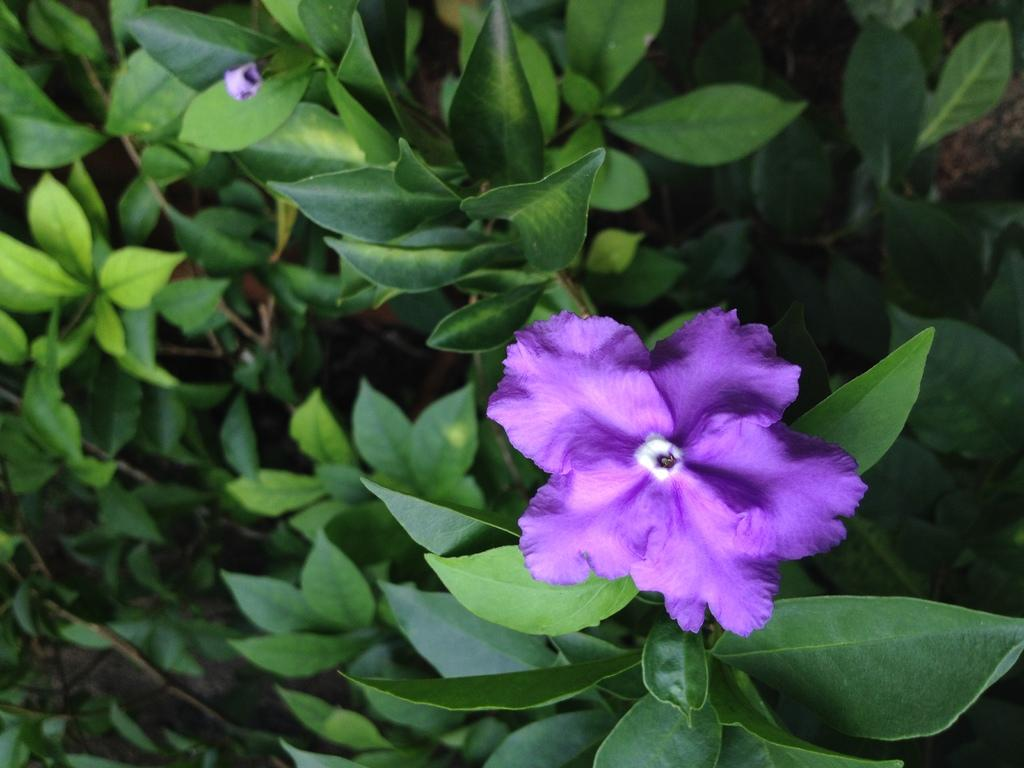What type of plant parts can be seen in the image? There are flowers, leaves, and stems in the image. Can you describe the flowers in the image? The flowers in the image have petals and various colors. What is the purpose of the stems in the image? The stems in the image provide support for the flowers and leaves. What type of leg can be seen in the image? There are no legs present in the image; it features flowers, leaves, and stems. How does the image evoke a sense of disgust? The image does not evoke a sense of disgust; it features flowers, leaves, and stems, which are generally considered pleasant and visually appealing. 